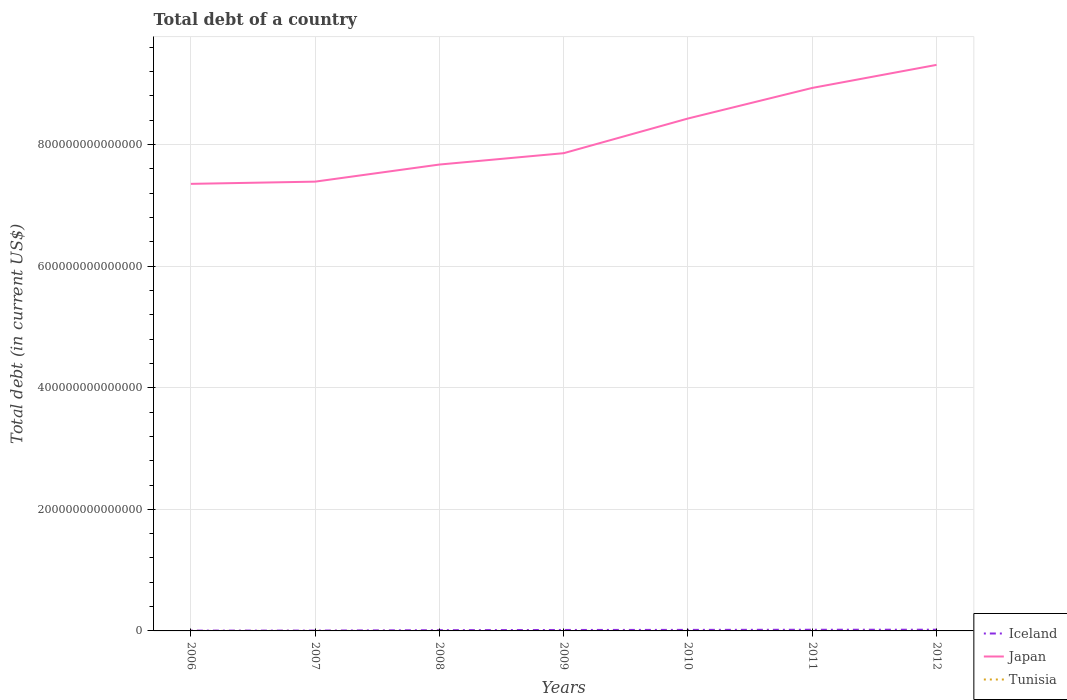Is the number of lines equal to the number of legend labels?
Provide a succinct answer. Yes. Across all years, what is the maximum debt in Japan?
Keep it short and to the point. 7.35e+14. In which year was the debt in Iceland maximum?
Offer a very short reply. 2006. What is the total debt in Iceland in the graph?
Offer a terse response. -4.20e+11. What is the difference between the highest and the second highest debt in Japan?
Offer a terse response. 1.96e+14. What is the difference between the highest and the lowest debt in Iceland?
Make the answer very short. 4. How many lines are there?
Keep it short and to the point. 3. What is the difference between two consecutive major ticks on the Y-axis?
Offer a terse response. 2.00e+14. Does the graph contain any zero values?
Provide a succinct answer. No. Does the graph contain grids?
Ensure brevity in your answer.  Yes. Where does the legend appear in the graph?
Ensure brevity in your answer.  Bottom right. How are the legend labels stacked?
Make the answer very short. Vertical. What is the title of the graph?
Your answer should be compact. Total debt of a country. Does "Vietnam" appear as one of the legend labels in the graph?
Ensure brevity in your answer.  No. What is the label or title of the X-axis?
Ensure brevity in your answer.  Years. What is the label or title of the Y-axis?
Offer a terse response. Total debt (in current US$). What is the Total debt (in current US$) of Iceland in 2006?
Provide a succinct answer. 5.18e+11. What is the Total debt (in current US$) in Japan in 2006?
Give a very brief answer. 7.35e+14. What is the Total debt (in current US$) of Tunisia in 2006?
Provide a succinct answer. 2.22e+1. What is the Total debt (in current US$) of Iceland in 2007?
Offer a terse response. 5.62e+11. What is the Total debt (in current US$) in Japan in 2007?
Offer a very short reply. 7.39e+14. What is the Total debt (in current US$) of Tunisia in 2007?
Your answer should be compact. 2.28e+1. What is the Total debt (in current US$) of Iceland in 2008?
Provide a succinct answer. 1.23e+12. What is the Total debt (in current US$) of Japan in 2008?
Offer a terse response. 7.67e+14. What is the Total debt (in current US$) of Tunisia in 2008?
Make the answer very short. 2.39e+1. What is the Total debt (in current US$) of Iceland in 2009?
Make the answer very short. 1.58e+12. What is the Total debt (in current US$) of Japan in 2009?
Provide a short and direct response. 7.86e+14. What is the Total debt (in current US$) of Tunisia in 2009?
Provide a succinct answer. 2.52e+1. What is the Total debt (in current US$) of Iceland in 2010?
Give a very brief answer. 1.71e+12. What is the Total debt (in current US$) of Japan in 2010?
Your answer should be compact. 8.43e+14. What is the Total debt (in current US$) of Tunisia in 2010?
Keep it short and to the point. 2.56e+1. What is the Total debt (in current US$) of Iceland in 2011?
Your answer should be compact. 1.92e+12. What is the Total debt (in current US$) of Japan in 2011?
Give a very brief answer. 8.93e+14. What is the Total debt (in current US$) of Tunisia in 2011?
Your response must be concise. 2.88e+1. What is the Total debt (in current US$) of Iceland in 2012?
Ensure brevity in your answer.  2.00e+12. What is the Total debt (in current US$) in Japan in 2012?
Your answer should be very brief. 9.31e+14. What is the Total debt (in current US$) in Tunisia in 2012?
Provide a succinct answer. 3.14e+1. Across all years, what is the maximum Total debt (in current US$) in Iceland?
Make the answer very short. 2.00e+12. Across all years, what is the maximum Total debt (in current US$) in Japan?
Your response must be concise. 9.31e+14. Across all years, what is the maximum Total debt (in current US$) in Tunisia?
Your answer should be compact. 3.14e+1. Across all years, what is the minimum Total debt (in current US$) in Iceland?
Your answer should be compact. 5.18e+11. Across all years, what is the minimum Total debt (in current US$) in Japan?
Your answer should be very brief. 7.35e+14. Across all years, what is the minimum Total debt (in current US$) in Tunisia?
Provide a succinct answer. 2.22e+1. What is the total Total debt (in current US$) of Iceland in the graph?
Give a very brief answer. 9.52e+12. What is the total Total debt (in current US$) of Japan in the graph?
Your answer should be compact. 5.70e+15. What is the total Total debt (in current US$) of Tunisia in the graph?
Your answer should be very brief. 1.80e+11. What is the difference between the Total debt (in current US$) of Iceland in 2006 and that in 2007?
Offer a very short reply. -4.37e+1. What is the difference between the Total debt (in current US$) in Japan in 2006 and that in 2007?
Keep it short and to the point. -3.65e+12. What is the difference between the Total debt (in current US$) of Tunisia in 2006 and that in 2007?
Provide a short and direct response. -6.08e+08. What is the difference between the Total debt (in current US$) of Iceland in 2006 and that in 2008?
Provide a short and direct response. -7.09e+11. What is the difference between the Total debt (in current US$) of Japan in 2006 and that in 2008?
Give a very brief answer. -3.18e+13. What is the difference between the Total debt (in current US$) of Tunisia in 2006 and that in 2008?
Provide a short and direct response. -1.71e+09. What is the difference between the Total debt (in current US$) of Iceland in 2006 and that in 2009?
Make the answer very short. -1.06e+12. What is the difference between the Total debt (in current US$) of Japan in 2006 and that in 2009?
Your answer should be compact. -5.05e+13. What is the difference between the Total debt (in current US$) in Tunisia in 2006 and that in 2009?
Offer a terse response. -2.97e+09. What is the difference between the Total debt (in current US$) of Iceland in 2006 and that in 2010?
Keep it short and to the point. -1.19e+12. What is the difference between the Total debt (in current US$) in Japan in 2006 and that in 2010?
Offer a very short reply. -1.08e+14. What is the difference between the Total debt (in current US$) in Tunisia in 2006 and that in 2010?
Provide a succinct answer. -3.42e+09. What is the difference between the Total debt (in current US$) of Iceland in 2006 and that in 2011?
Offer a terse response. -1.40e+12. What is the difference between the Total debt (in current US$) of Japan in 2006 and that in 2011?
Make the answer very short. -1.58e+14. What is the difference between the Total debt (in current US$) of Tunisia in 2006 and that in 2011?
Provide a short and direct response. -6.56e+09. What is the difference between the Total debt (in current US$) in Iceland in 2006 and that in 2012?
Ensure brevity in your answer.  -1.48e+12. What is the difference between the Total debt (in current US$) of Japan in 2006 and that in 2012?
Make the answer very short. -1.96e+14. What is the difference between the Total debt (in current US$) in Tunisia in 2006 and that in 2012?
Keep it short and to the point. -9.20e+09. What is the difference between the Total debt (in current US$) of Iceland in 2007 and that in 2008?
Your response must be concise. -6.65e+11. What is the difference between the Total debt (in current US$) in Japan in 2007 and that in 2008?
Offer a terse response. -2.81e+13. What is the difference between the Total debt (in current US$) of Tunisia in 2007 and that in 2008?
Provide a succinct answer. -1.10e+09. What is the difference between the Total debt (in current US$) of Iceland in 2007 and that in 2009?
Offer a terse response. -1.02e+12. What is the difference between the Total debt (in current US$) in Japan in 2007 and that in 2009?
Give a very brief answer. -4.68e+13. What is the difference between the Total debt (in current US$) in Tunisia in 2007 and that in 2009?
Your answer should be very brief. -2.36e+09. What is the difference between the Total debt (in current US$) in Iceland in 2007 and that in 2010?
Offer a terse response. -1.15e+12. What is the difference between the Total debt (in current US$) in Japan in 2007 and that in 2010?
Offer a terse response. -1.04e+14. What is the difference between the Total debt (in current US$) of Tunisia in 2007 and that in 2010?
Offer a terse response. -2.81e+09. What is the difference between the Total debt (in current US$) of Iceland in 2007 and that in 2011?
Keep it short and to the point. -1.36e+12. What is the difference between the Total debt (in current US$) in Japan in 2007 and that in 2011?
Keep it short and to the point. -1.54e+14. What is the difference between the Total debt (in current US$) of Tunisia in 2007 and that in 2011?
Provide a succinct answer. -5.95e+09. What is the difference between the Total debt (in current US$) of Iceland in 2007 and that in 2012?
Make the answer very short. -1.44e+12. What is the difference between the Total debt (in current US$) of Japan in 2007 and that in 2012?
Offer a very short reply. -1.92e+14. What is the difference between the Total debt (in current US$) in Tunisia in 2007 and that in 2012?
Give a very brief answer. -8.59e+09. What is the difference between the Total debt (in current US$) in Iceland in 2008 and that in 2009?
Offer a very short reply. -3.50e+11. What is the difference between the Total debt (in current US$) of Japan in 2008 and that in 2009?
Your answer should be very brief. -1.87e+13. What is the difference between the Total debt (in current US$) in Tunisia in 2008 and that in 2009?
Provide a short and direct response. -1.26e+09. What is the difference between the Total debt (in current US$) in Iceland in 2008 and that in 2010?
Offer a very short reply. -4.86e+11. What is the difference between the Total debt (in current US$) of Japan in 2008 and that in 2010?
Provide a succinct answer. -7.57e+13. What is the difference between the Total debt (in current US$) in Tunisia in 2008 and that in 2010?
Ensure brevity in your answer.  -1.71e+09. What is the difference between the Total debt (in current US$) of Iceland in 2008 and that in 2011?
Offer a very short reply. -6.95e+11. What is the difference between the Total debt (in current US$) in Japan in 2008 and that in 2011?
Provide a short and direct response. -1.26e+14. What is the difference between the Total debt (in current US$) in Tunisia in 2008 and that in 2011?
Provide a succinct answer. -4.85e+09. What is the difference between the Total debt (in current US$) in Iceland in 2008 and that in 2012?
Provide a short and direct response. -7.70e+11. What is the difference between the Total debt (in current US$) in Japan in 2008 and that in 2012?
Keep it short and to the point. -1.64e+14. What is the difference between the Total debt (in current US$) in Tunisia in 2008 and that in 2012?
Your response must be concise. -7.49e+09. What is the difference between the Total debt (in current US$) in Iceland in 2009 and that in 2010?
Provide a short and direct response. -1.36e+11. What is the difference between the Total debt (in current US$) of Japan in 2009 and that in 2010?
Your response must be concise. -5.71e+13. What is the difference between the Total debt (in current US$) of Tunisia in 2009 and that in 2010?
Offer a very short reply. -4.50e+08. What is the difference between the Total debt (in current US$) in Iceland in 2009 and that in 2011?
Provide a succinct answer. -3.44e+11. What is the difference between the Total debt (in current US$) in Japan in 2009 and that in 2011?
Your response must be concise. -1.07e+14. What is the difference between the Total debt (in current US$) in Tunisia in 2009 and that in 2011?
Provide a short and direct response. -3.59e+09. What is the difference between the Total debt (in current US$) of Iceland in 2009 and that in 2012?
Ensure brevity in your answer.  -4.20e+11. What is the difference between the Total debt (in current US$) of Japan in 2009 and that in 2012?
Your response must be concise. -1.45e+14. What is the difference between the Total debt (in current US$) of Tunisia in 2009 and that in 2012?
Your answer should be compact. -6.23e+09. What is the difference between the Total debt (in current US$) in Iceland in 2010 and that in 2011?
Make the answer very short. -2.09e+11. What is the difference between the Total debt (in current US$) of Japan in 2010 and that in 2011?
Provide a short and direct response. -5.03e+13. What is the difference between the Total debt (in current US$) of Tunisia in 2010 and that in 2011?
Give a very brief answer. -3.14e+09. What is the difference between the Total debt (in current US$) in Iceland in 2010 and that in 2012?
Provide a succinct answer. -2.84e+11. What is the difference between the Total debt (in current US$) in Japan in 2010 and that in 2012?
Provide a short and direct response. -8.82e+13. What is the difference between the Total debt (in current US$) of Tunisia in 2010 and that in 2012?
Give a very brief answer. -5.78e+09. What is the difference between the Total debt (in current US$) in Iceland in 2011 and that in 2012?
Your response must be concise. -7.56e+1. What is the difference between the Total debt (in current US$) of Japan in 2011 and that in 2012?
Provide a succinct answer. -3.79e+13. What is the difference between the Total debt (in current US$) in Tunisia in 2011 and that in 2012?
Offer a terse response. -2.64e+09. What is the difference between the Total debt (in current US$) of Iceland in 2006 and the Total debt (in current US$) of Japan in 2007?
Give a very brief answer. -7.39e+14. What is the difference between the Total debt (in current US$) of Iceland in 2006 and the Total debt (in current US$) of Tunisia in 2007?
Your answer should be very brief. 4.96e+11. What is the difference between the Total debt (in current US$) in Japan in 2006 and the Total debt (in current US$) in Tunisia in 2007?
Your answer should be compact. 7.35e+14. What is the difference between the Total debt (in current US$) in Iceland in 2006 and the Total debt (in current US$) in Japan in 2008?
Make the answer very short. -7.67e+14. What is the difference between the Total debt (in current US$) in Iceland in 2006 and the Total debt (in current US$) in Tunisia in 2008?
Make the answer very short. 4.94e+11. What is the difference between the Total debt (in current US$) in Japan in 2006 and the Total debt (in current US$) in Tunisia in 2008?
Ensure brevity in your answer.  7.35e+14. What is the difference between the Total debt (in current US$) of Iceland in 2006 and the Total debt (in current US$) of Japan in 2009?
Make the answer very short. -7.85e+14. What is the difference between the Total debt (in current US$) of Iceland in 2006 and the Total debt (in current US$) of Tunisia in 2009?
Keep it short and to the point. 4.93e+11. What is the difference between the Total debt (in current US$) in Japan in 2006 and the Total debt (in current US$) in Tunisia in 2009?
Your response must be concise. 7.35e+14. What is the difference between the Total debt (in current US$) in Iceland in 2006 and the Total debt (in current US$) in Japan in 2010?
Provide a short and direct response. -8.42e+14. What is the difference between the Total debt (in current US$) in Iceland in 2006 and the Total debt (in current US$) in Tunisia in 2010?
Your answer should be very brief. 4.93e+11. What is the difference between the Total debt (in current US$) of Japan in 2006 and the Total debt (in current US$) of Tunisia in 2010?
Provide a short and direct response. 7.35e+14. What is the difference between the Total debt (in current US$) in Iceland in 2006 and the Total debt (in current US$) in Japan in 2011?
Your response must be concise. -8.93e+14. What is the difference between the Total debt (in current US$) in Iceland in 2006 and the Total debt (in current US$) in Tunisia in 2011?
Offer a very short reply. 4.90e+11. What is the difference between the Total debt (in current US$) in Japan in 2006 and the Total debt (in current US$) in Tunisia in 2011?
Keep it short and to the point. 7.35e+14. What is the difference between the Total debt (in current US$) in Iceland in 2006 and the Total debt (in current US$) in Japan in 2012?
Offer a terse response. -9.31e+14. What is the difference between the Total debt (in current US$) of Iceland in 2006 and the Total debt (in current US$) of Tunisia in 2012?
Offer a terse response. 4.87e+11. What is the difference between the Total debt (in current US$) of Japan in 2006 and the Total debt (in current US$) of Tunisia in 2012?
Your response must be concise. 7.35e+14. What is the difference between the Total debt (in current US$) in Iceland in 2007 and the Total debt (in current US$) in Japan in 2008?
Provide a succinct answer. -7.67e+14. What is the difference between the Total debt (in current US$) of Iceland in 2007 and the Total debt (in current US$) of Tunisia in 2008?
Offer a very short reply. 5.38e+11. What is the difference between the Total debt (in current US$) of Japan in 2007 and the Total debt (in current US$) of Tunisia in 2008?
Make the answer very short. 7.39e+14. What is the difference between the Total debt (in current US$) of Iceland in 2007 and the Total debt (in current US$) of Japan in 2009?
Ensure brevity in your answer.  -7.85e+14. What is the difference between the Total debt (in current US$) in Iceland in 2007 and the Total debt (in current US$) in Tunisia in 2009?
Your response must be concise. 5.37e+11. What is the difference between the Total debt (in current US$) of Japan in 2007 and the Total debt (in current US$) of Tunisia in 2009?
Your answer should be very brief. 7.39e+14. What is the difference between the Total debt (in current US$) in Iceland in 2007 and the Total debt (in current US$) in Japan in 2010?
Offer a terse response. -8.42e+14. What is the difference between the Total debt (in current US$) of Iceland in 2007 and the Total debt (in current US$) of Tunisia in 2010?
Provide a succinct answer. 5.36e+11. What is the difference between the Total debt (in current US$) of Japan in 2007 and the Total debt (in current US$) of Tunisia in 2010?
Offer a terse response. 7.39e+14. What is the difference between the Total debt (in current US$) in Iceland in 2007 and the Total debt (in current US$) in Japan in 2011?
Your answer should be very brief. -8.93e+14. What is the difference between the Total debt (in current US$) in Iceland in 2007 and the Total debt (in current US$) in Tunisia in 2011?
Your answer should be very brief. 5.33e+11. What is the difference between the Total debt (in current US$) of Japan in 2007 and the Total debt (in current US$) of Tunisia in 2011?
Make the answer very short. 7.39e+14. What is the difference between the Total debt (in current US$) of Iceland in 2007 and the Total debt (in current US$) of Japan in 2012?
Give a very brief answer. -9.31e+14. What is the difference between the Total debt (in current US$) in Iceland in 2007 and the Total debt (in current US$) in Tunisia in 2012?
Provide a short and direct response. 5.31e+11. What is the difference between the Total debt (in current US$) of Japan in 2007 and the Total debt (in current US$) of Tunisia in 2012?
Make the answer very short. 7.39e+14. What is the difference between the Total debt (in current US$) of Iceland in 2008 and the Total debt (in current US$) of Japan in 2009?
Ensure brevity in your answer.  -7.85e+14. What is the difference between the Total debt (in current US$) in Iceland in 2008 and the Total debt (in current US$) in Tunisia in 2009?
Keep it short and to the point. 1.20e+12. What is the difference between the Total debt (in current US$) of Japan in 2008 and the Total debt (in current US$) of Tunisia in 2009?
Make the answer very short. 7.67e+14. What is the difference between the Total debt (in current US$) of Iceland in 2008 and the Total debt (in current US$) of Japan in 2010?
Provide a succinct answer. -8.42e+14. What is the difference between the Total debt (in current US$) of Iceland in 2008 and the Total debt (in current US$) of Tunisia in 2010?
Provide a short and direct response. 1.20e+12. What is the difference between the Total debt (in current US$) of Japan in 2008 and the Total debt (in current US$) of Tunisia in 2010?
Your response must be concise. 7.67e+14. What is the difference between the Total debt (in current US$) in Iceland in 2008 and the Total debt (in current US$) in Japan in 2011?
Give a very brief answer. -8.92e+14. What is the difference between the Total debt (in current US$) in Iceland in 2008 and the Total debt (in current US$) in Tunisia in 2011?
Ensure brevity in your answer.  1.20e+12. What is the difference between the Total debt (in current US$) of Japan in 2008 and the Total debt (in current US$) of Tunisia in 2011?
Your answer should be very brief. 7.67e+14. What is the difference between the Total debt (in current US$) in Iceland in 2008 and the Total debt (in current US$) in Japan in 2012?
Your answer should be compact. -9.30e+14. What is the difference between the Total debt (in current US$) in Iceland in 2008 and the Total debt (in current US$) in Tunisia in 2012?
Your answer should be compact. 1.20e+12. What is the difference between the Total debt (in current US$) in Japan in 2008 and the Total debt (in current US$) in Tunisia in 2012?
Offer a terse response. 7.67e+14. What is the difference between the Total debt (in current US$) of Iceland in 2009 and the Total debt (in current US$) of Japan in 2010?
Your answer should be compact. -8.41e+14. What is the difference between the Total debt (in current US$) in Iceland in 2009 and the Total debt (in current US$) in Tunisia in 2010?
Your answer should be very brief. 1.55e+12. What is the difference between the Total debt (in current US$) in Japan in 2009 and the Total debt (in current US$) in Tunisia in 2010?
Your response must be concise. 7.86e+14. What is the difference between the Total debt (in current US$) in Iceland in 2009 and the Total debt (in current US$) in Japan in 2011?
Keep it short and to the point. -8.92e+14. What is the difference between the Total debt (in current US$) of Iceland in 2009 and the Total debt (in current US$) of Tunisia in 2011?
Make the answer very short. 1.55e+12. What is the difference between the Total debt (in current US$) of Japan in 2009 and the Total debt (in current US$) of Tunisia in 2011?
Make the answer very short. 7.86e+14. What is the difference between the Total debt (in current US$) of Iceland in 2009 and the Total debt (in current US$) of Japan in 2012?
Give a very brief answer. -9.30e+14. What is the difference between the Total debt (in current US$) of Iceland in 2009 and the Total debt (in current US$) of Tunisia in 2012?
Offer a terse response. 1.55e+12. What is the difference between the Total debt (in current US$) in Japan in 2009 and the Total debt (in current US$) in Tunisia in 2012?
Offer a very short reply. 7.86e+14. What is the difference between the Total debt (in current US$) of Iceland in 2010 and the Total debt (in current US$) of Japan in 2011?
Your answer should be compact. -8.92e+14. What is the difference between the Total debt (in current US$) in Iceland in 2010 and the Total debt (in current US$) in Tunisia in 2011?
Provide a succinct answer. 1.68e+12. What is the difference between the Total debt (in current US$) in Japan in 2010 and the Total debt (in current US$) in Tunisia in 2011?
Offer a very short reply. 8.43e+14. What is the difference between the Total debt (in current US$) in Iceland in 2010 and the Total debt (in current US$) in Japan in 2012?
Provide a short and direct response. -9.29e+14. What is the difference between the Total debt (in current US$) in Iceland in 2010 and the Total debt (in current US$) in Tunisia in 2012?
Ensure brevity in your answer.  1.68e+12. What is the difference between the Total debt (in current US$) in Japan in 2010 and the Total debt (in current US$) in Tunisia in 2012?
Ensure brevity in your answer.  8.43e+14. What is the difference between the Total debt (in current US$) of Iceland in 2011 and the Total debt (in current US$) of Japan in 2012?
Give a very brief answer. -9.29e+14. What is the difference between the Total debt (in current US$) of Iceland in 2011 and the Total debt (in current US$) of Tunisia in 2012?
Offer a terse response. 1.89e+12. What is the difference between the Total debt (in current US$) in Japan in 2011 and the Total debt (in current US$) in Tunisia in 2012?
Provide a short and direct response. 8.93e+14. What is the average Total debt (in current US$) of Iceland per year?
Keep it short and to the point. 1.36e+12. What is the average Total debt (in current US$) of Japan per year?
Your answer should be compact. 8.14e+14. What is the average Total debt (in current US$) of Tunisia per year?
Provide a succinct answer. 2.57e+1. In the year 2006, what is the difference between the Total debt (in current US$) in Iceland and Total debt (in current US$) in Japan?
Make the answer very short. -7.35e+14. In the year 2006, what is the difference between the Total debt (in current US$) in Iceland and Total debt (in current US$) in Tunisia?
Make the answer very short. 4.96e+11. In the year 2006, what is the difference between the Total debt (in current US$) of Japan and Total debt (in current US$) of Tunisia?
Offer a very short reply. 7.35e+14. In the year 2007, what is the difference between the Total debt (in current US$) in Iceland and Total debt (in current US$) in Japan?
Your answer should be compact. -7.39e+14. In the year 2007, what is the difference between the Total debt (in current US$) of Iceland and Total debt (in current US$) of Tunisia?
Provide a short and direct response. 5.39e+11. In the year 2007, what is the difference between the Total debt (in current US$) in Japan and Total debt (in current US$) in Tunisia?
Your response must be concise. 7.39e+14. In the year 2008, what is the difference between the Total debt (in current US$) of Iceland and Total debt (in current US$) of Japan?
Offer a terse response. -7.66e+14. In the year 2008, what is the difference between the Total debt (in current US$) in Iceland and Total debt (in current US$) in Tunisia?
Your answer should be very brief. 1.20e+12. In the year 2008, what is the difference between the Total debt (in current US$) of Japan and Total debt (in current US$) of Tunisia?
Your response must be concise. 7.67e+14. In the year 2009, what is the difference between the Total debt (in current US$) of Iceland and Total debt (in current US$) of Japan?
Make the answer very short. -7.84e+14. In the year 2009, what is the difference between the Total debt (in current US$) of Iceland and Total debt (in current US$) of Tunisia?
Provide a short and direct response. 1.55e+12. In the year 2009, what is the difference between the Total debt (in current US$) in Japan and Total debt (in current US$) in Tunisia?
Your answer should be very brief. 7.86e+14. In the year 2010, what is the difference between the Total debt (in current US$) of Iceland and Total debt (in current US$) of Japan?
Keep it short and to the point. -8.41e+14. In the year 2010, what is the difference between the Total debt (in current US$) in Iceland and Total debt (in current US$) in Tunisia?
Offer a terse response. 1.69e+12. In the year 2010, what is the difference between the Total debt (in current US$) in Japan and Total debt (in current US$) in Tunisia?
Offer a terse response. 8.43e+14. In the year 2011, what is the difference between the Total debt (in current US$) of Iceland and Total debt (in current US$) of Japan?
Offer a very short reply. -8.91e+14. In the year 2011, what is the difference between the Total debt (in current US$) in Iceland and Total debt (in current US$) in Tunisia?
Offer a terse response. 1.89e+12. In the year 2011, what is the difference between the Total debt (in current US$) of Japan and Total debt (in current US$) of Tunisia?
Your answer should be compact. 8.93e+14. In the year 2012, what is the difference between the Total debt (in current US$) of Iceland and Total debt (in current US$) of Japan?
Keep it short and to the point. -9.29e+14. In the year 2012, what is the difference between the Total debt (in current US$) in Iceland and Total debt (in current US$) in Tunisia?
Your answer should be compact. 1.97e+12. In the year 2012, what is the difference between the Total debt (in current US$) of Japan and Total debt (in current US$) of Tunisia?
Make the answer very short. 9.31e+14. What is the ratio of the Total debt (in current US$) of Iceland in 2006 to that in 2007?
Provide a short and direct response. 0.92. What is the ratio of the Total debt (in current US$) in Tunisia in 2006 to that in 2007?
Your answer should be compact. 0.97. What is the ratio of the Total debt (in current US$) in Iceland in 2006 to that in 2008?
Your answer should be very brief. 0.42. What is the ratio of the Total debt (in current US$) in Japan in 2006 to that in 2008?
Offer a terse response. 0.96. What is the ratio of the Total debt (in current US$) of Tunisia in 2006 to that in 2008?
Keep it short and to the point. 0.93. What is the ratio of the Total debt (in current US$) in Iceland in 2006 to that in 2009?
Your response must be concise. 0.33. What is the ratio of the Total debt (in current US$) in Japan in 2006 to that in 2009?
Your answer should be compact. 0.94. What is the ratio of the Total debt (in current US$) of Tunisia in 2006 to that in 2009?
Provide a succinct answer. 0.88. What is the ratio of the Total debt (in current US$) of Iceland in 2006 to that in 2010?
Provide a succinct answer. 0.3. What is the ratio of the Total debt (in current US$) in Japan in 2006 to that in 2010?
Give a very brief answer. 0.87. What is the ratio of the Total debt (in current US$) of Tunisia in 2006 to that in 2010?
Make the answer very short. 0.87. What is the ratio of the Total debt (in current US$) in Iceland in 2006 to that in 2011?
Provide a short and direct response. 0.27. What is the ratio of the Total debt (in current US$) in Japan in 2006 to that in 2011?
Offer a terse response. 0.82. What is the ratio of the Total debt (in current US$) in Tunisia in 2006 to that in 2011?
Provide a short and direct response. 0.77. What is the ratio of the Total debt (in current US$) in Iceland in 2006 to that in 2012?
Provide a succinct answer. 0.26. What is the ratio of the Total debt (in current US$) in Japan in 2006 to that in 2012?
Your response must be concise. 0.79. What is the ratio of the Total debt (in current US$) in Tunisia in 2006 to that in 2012?
Give a very brief answer. 0.71. What is the ratio of the Total debt (in current US$) in Iceland in 2007 to that in 2008?
Provide a short and direct response. 0.46. What is the ratio of the Total debt (in current US$) in Japan in 2007 to that in 2008?
Your response must be concise. 0.96. What is the ratio of the Total debt (in current US$) of Tunisia in 2007 to that in 2008?
Your answer should be very brief. 0.95. What is the ratio of the Total debt (in current US$) of Iceland in 2007 to that in 2009?
Give a very brief answer. 0.36. What is the ratio of the Total debt (in current US$) of Japan in 2007 to that in 2009?
Your response must be concise. 0.94. What is the ratio of the Total debt (in current US$) in Tunisia in 2007 to that in 2009?
Your answer should be very brief. 0.91. What is the ratio of the Total debt (in current US$) of Iceland in 2007 to that in 2010?
Offer a very short reply. 0.33. What is the ratio of the Total debt (in current US$) in Japan in 2007 to that in 2010?
Make the answer very short. 0.88. What is the ratio of the Total debt (in current US$) of Tunisia in 2007 to that in 2010?
Offer a very short reply. 0.89. What is the ratio of the Total debt (in current US$) of Iceland in 2007 to that in 2011?
Ensure brevity in your answer.  0.29. What is the ratio of the Total debt (in current US$) in Japan in 2007 to that in 2011?
Make the answer very short. 0.83. What is the ratio of the Total debt (in current US$) of Tunisia in 2007 to that in 2011?
Offer a very short reply. 0.79. What is the ratio of the Total debt (in current US$) of Iceland in 2007 to that in 2012?
Your answer should be compact. 0.28. What is the ratio of the Total debt (in current US$) in Japan in 2007 to that in 2012?
Your answer should be very brief. 0.79. What is the ratio of the Total debt (in current US$) of Tunisia in 2007 to that in 2012?
Offer a terse response. 0.73. What is the ratio of the Total debt (in current US$) of Iceland in 2008 to that in 2009?
Keep it short and to the point. 0.78. What is the ratio of the Total debt (in current US$) of Japan in 2008 to that in 2009?
Your answer should be compact. 0.98. What is the ratio of the Total debt (in current US$) in Tunisia in 2008 to that in 2009?
Make the answer very short. 0.95. What is the ratio of the Total debt (in current US$) of Iceland in 2008 to that in 2010?
Offer a terse response. 0.72. What is the ratio of the Total debt (in current US$) of Japan in 2008 to that in 2010?
Give a very brief answer. 0.91. What is the ratio of the Total debt (in current US$) in Tunisia in 2008 to that in 2010?
Ensure brevity in your answer.  0.93. What is the ratio of the Total debt (in current US$) in Iceland in 2008 to that in 2011?
Provide a short and direct response. 0.64. What is the ratio of the Total debt (in current US$) in Japan in 2008 to that in 2011?
Offer a very short reply. 0.86. What is the ratio of the Total debt (in current US$) in Tunisia in 2008 to that in 2011?
Offer a terse response. 0.83. What is the ratio of the Total debt (in current US$) of Iceland in 2008 to that in 2012?
Make the answer very short. 0.61. What is the ratio of the Total debt (in current US$) of Japan in 2008 to that in 2012?
Your answer should be very brief. 0.82. What is the ratio of the Total debt (in current US$) in Tunisia in 2008 to that in 2012?
Your response must be concise. 0.76. What is the ratio of the Total debt (in current US$) of Iceland in 2009 to that in 2010?
Offer a very short reply. 0.92. What is the ratio of the Total debt (in current US$) of Japan in 2009 to that in 2010?
Provide a short and direct response. 0.93. What is the ratio of the Total debt (in current US$) of Tunisia in 2009 to that in 2010?
Give a very brief answer. 0.98. What is the ratio of the Total debt (in current US$) in Iceland in 2009 to that in 2011?
Provide a short and direct response. 0.82. What is the ratio of the Total debt (in current US$) of Japan in 2009 to that in 2011?
Give a very brief answer. 0.88. What is the ratio of the Total debt (in current US$) of Tunisia in 2009 to that in 2011?
Your answer should be compact. 0.88. What is the ratio of the Total debt (in current US$) of Iceland in 2009 to that in 2012?
Give a very brief answer. 0.79. What is the ratio of the Total debt (in current US$) in Japan in 2009 to that in 2012?
Your response must be concise. 0.84. What is the ratio of the Total debt (in current US$) of Tunisia in 2009 to that in 2012?
Ensure brevity in your answer.  0.8. What is the ratio of the Total debt (in current US$) of Iceland in 2010 to that in 2011?
Ensure brevity in your answer.  0.89. What is the ratio of the Total debt (in current US$) of Japan in 2010 to that in 2011?
Offer a terse response. 0.94. What is the ratio of the Total debt (in current US$) of Tunisia in 2010 to that in 2011?
Keep it short and to the point. 0.89. What is the ratio of the Total debt (in current US$) in Iceland in 2010 to that in 2012?
Give a very brief answer. 0.86. What is the ratio of the Total debt (in current US$) in Japan in 2010 to that in 2012?
Ensure brevity in your answer.  0.91. What is the ratio of the Total debt (in current US$) in Tunisia in 2010 to that in 2012?
Make the answer very short. 0.82. What is the ratio of the Total debt (in current US$) of Iceland in 2011 to that in 2012?
Ensure brevity in your answer.  0.96. What is the ratio of the Total debt (in current US$) in Japan in 2011 to that in 2012?
Offer a terse response. 0.96. What is the ratio of the Total debt (in current US$) of Tunisia in 2011 to that in 2012?
Keep it short and to the point. 0.92. What is the difference between the highest and the second highest Total debt (in current US$) in Iceland?
Ensure brevity in your answer.  7.56e+1. What is the difference between the highest and the second highest Total debt (in current US$) in Japan?
Keep it short and to the point. 3.79e+13. What is the difference between the highest and the second highest Total debt (in current US$) in Tunisia?
Your answer should be very brief. 2.64e+09. What is the difference between the highest and the lowest Total debt (in current US$) of Iceland?
Make the answer very short. 1.48e+12. What is the difference between the highest and the lowest Total debt (in current US$) of Japan?
Make the answer very short. 1.96e+14. What is the difference between the highest and the lowest Total debt (in current US$) in Tunisia?
Your answer should be compact. 9.20e+09. 